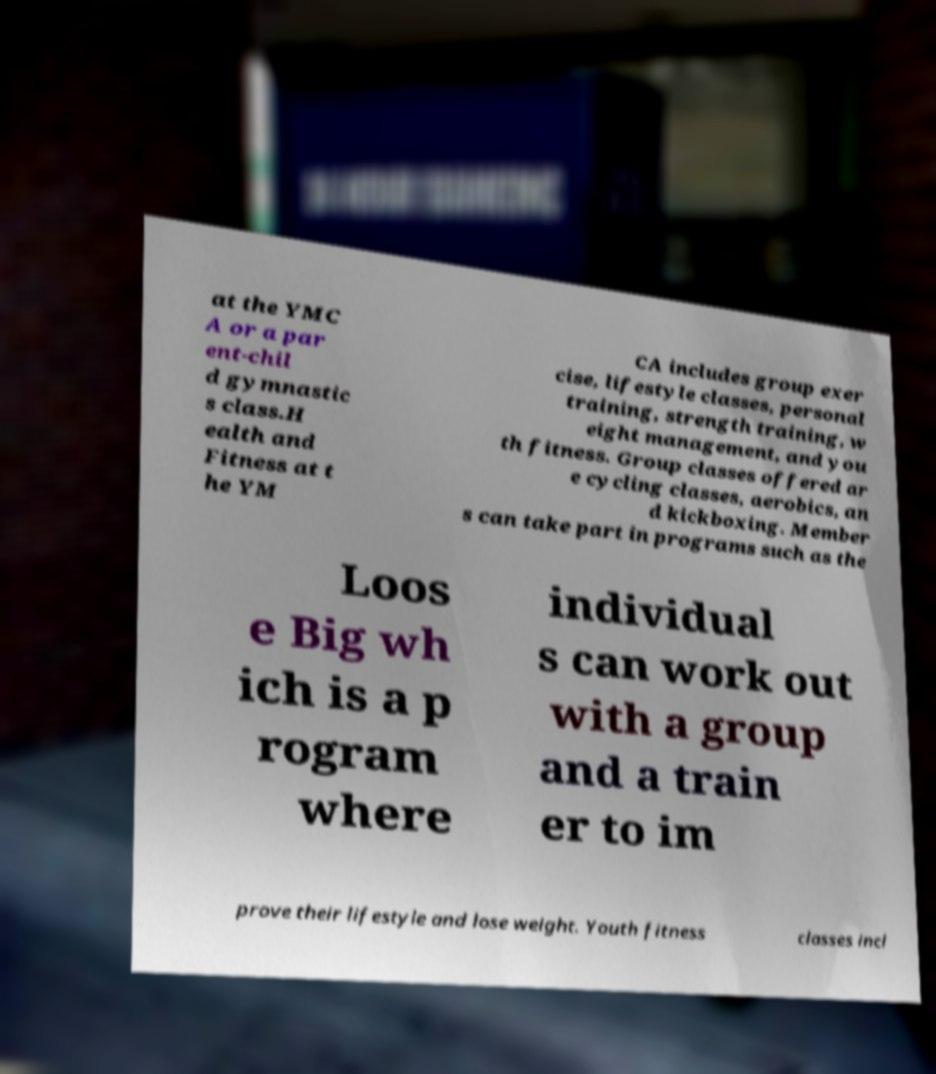There's text embedded in this image that I need extracted. Can you transcribe it verbatim? at the YMC A or a par ent-chil d gymnastic s class.H ealth and Fitness at t he YM CA includes group exer cise, lifestyle classes, personal training, strength training, w eight management, and you th fitness. Group classes offered ar e cycling classes, aerobics, an d kickboxing. Member s can take part in programs such as the Loos e Big wh ich is a p rogram where individual s can work out with a group and a train er to im prove their lifestyle and lose weight. Youth fitness classes incl 